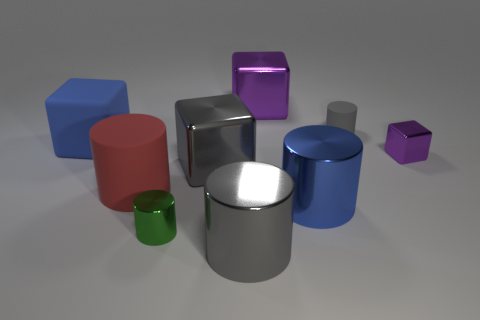Subtract all tiny purple cubes. How many cubes are left? 3 Add 1 gray metal blocks. How many objects exist? 10 Subtract all gray cubes. How many gray cylinders are left? 2 Subtract all blue blocks. How many blocks are left? 3 Subtract all cylinders. How many objects are left? 4 Subtract 3 cylinders. How many cylinders are left? 2 Subtract all gray cubes. Subtract all yellow cylinders. How many cubes are left? 3 Subtract all large brown matte cylinders. Subtract all small green metal objects. How many objects are left? 8 Add 4 blue cylinders. How many blue cylinders are left? 5 Add 1 gray metal things. How many gray metal things exist? 3 